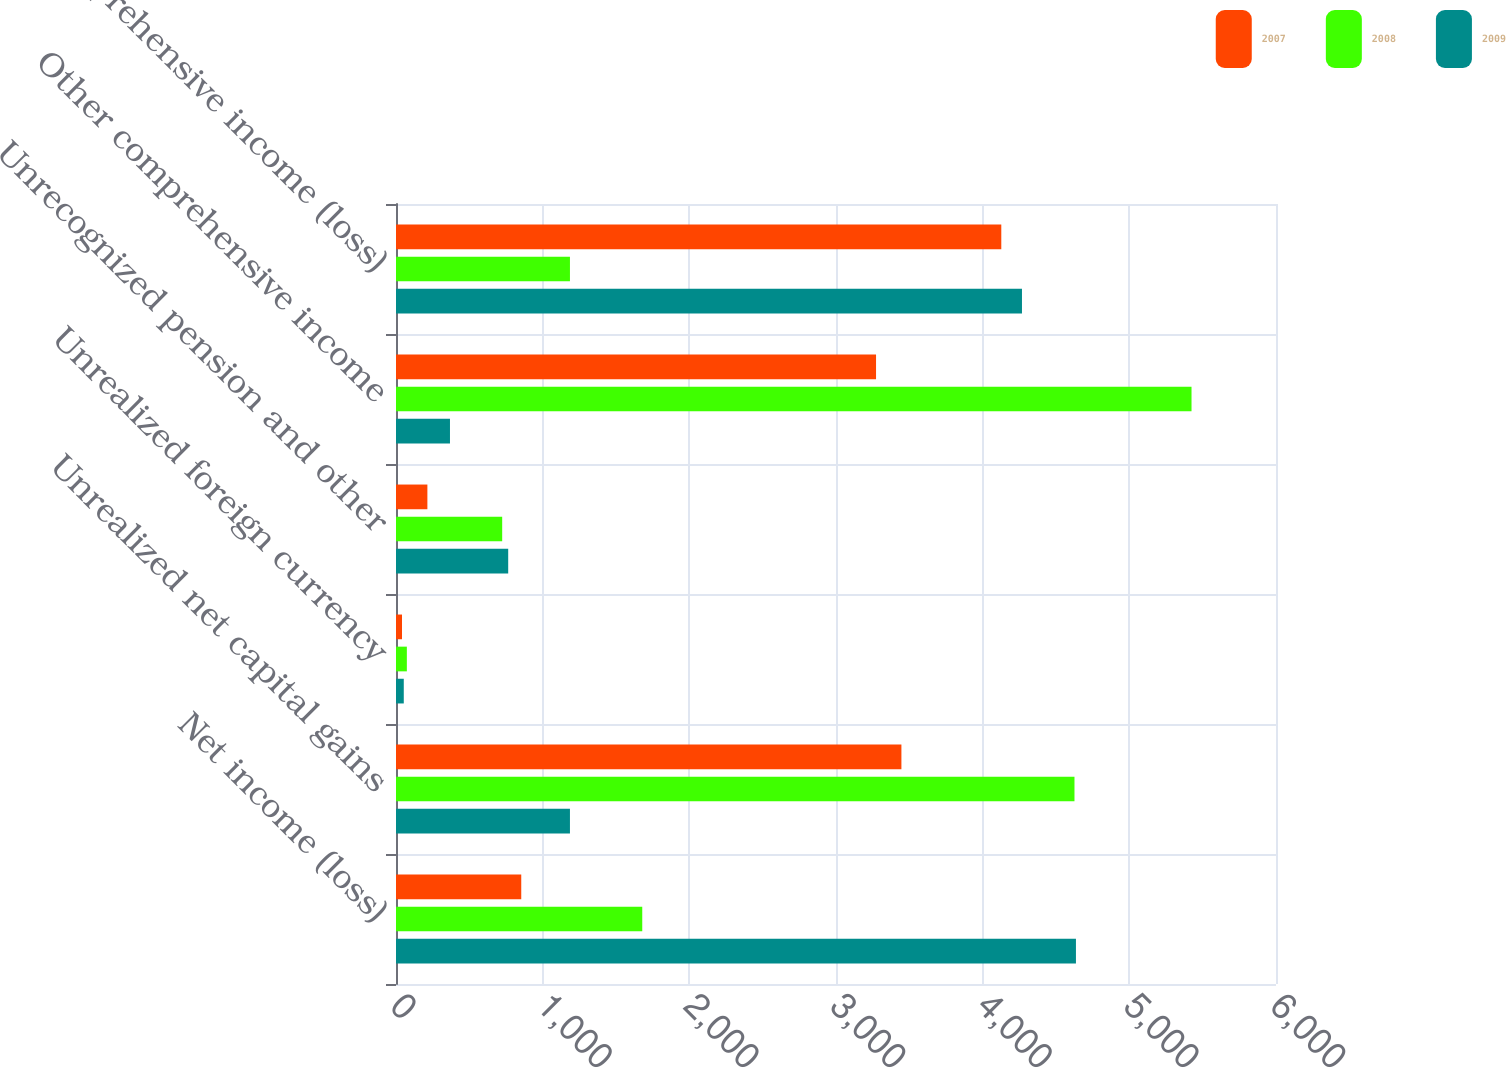Convert chart. <chart><loc_0><loc_0><loc_500><loc_500><stacked_bar_chart><ecel><fcel>Net income (loss)<fcel>Unrealized net capital gains<fcel>Unrealized foreign currency<fcel>Unrecognized pension and other<fcel>Other comprehensive income<fcel>Comprehensive income (loss)<nl><fcel>2007<fcel>854<fcel>3446<fcel>41<fcel>214<fcel>3273<fcel>4127<nl><fcel>2008<fcel>1679<fcel>4626<fcel>74<fcel>724<fcel>5424<fcel>1186<nl><fcel>2009<fcel>4636<fcel>1186<fcel>53<fcel>765<fcel>368<fcel>4268<nl></chart> 